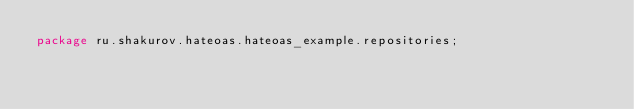<code> <loc_0><loc_0><loc_500><loc_500><_Java_>package ru.shakurov.hateoas.hateoas_example.repositories;
</code> 